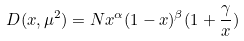Convert formula to latex. <formula><loc_0><loc_0><loc_500><loc_500>D ( x , \mu ^ { 2 } ) = N x ^ { \alpha } ( 1 - x ) ^ { \beta } ( 1 + \frac { \gamma } { x } )</formula> 